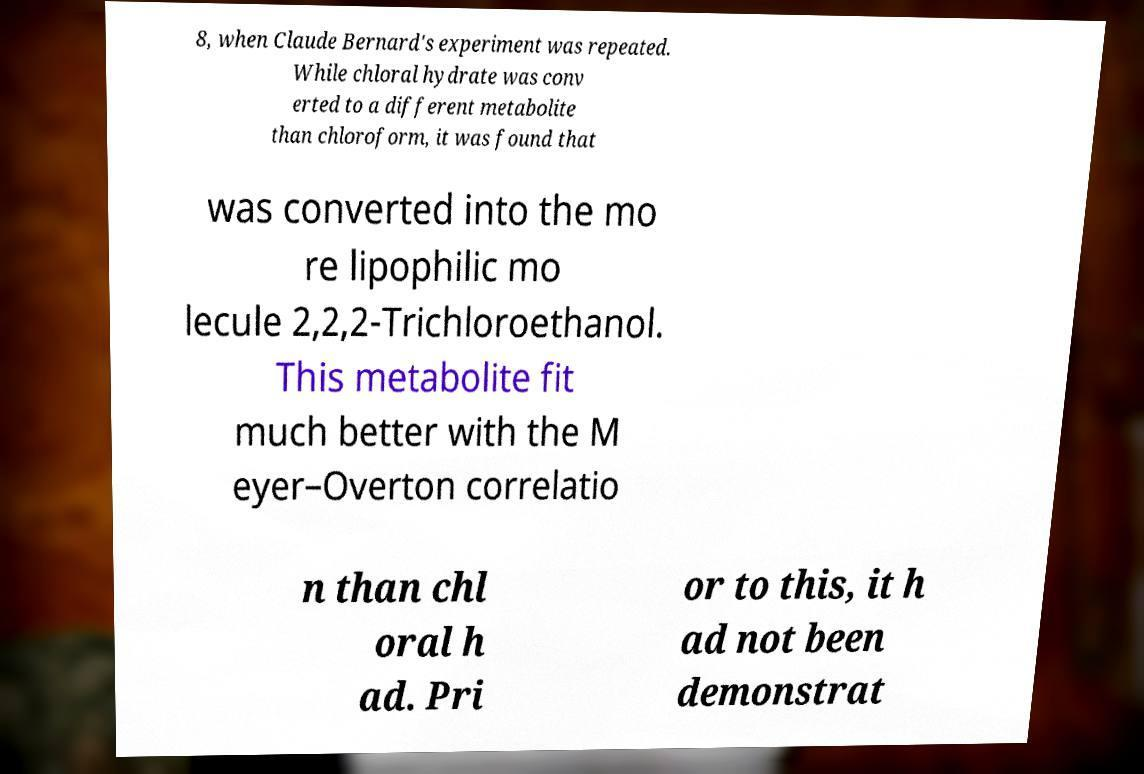Please identify and transcribe the text found in this image. 8, when Claude Bernard's experiment was repeated. While chloral hydrate was conv erted to a different metabolite than chloroform, it was found that was converted into the mo re lipophilic mo lecule 2,2,2-Trichloroethanol. This metabolite fit much better with the M eyer–Overton correlatio n than chl oral h ad. Pri or to this, it h ad not been demonstrat 